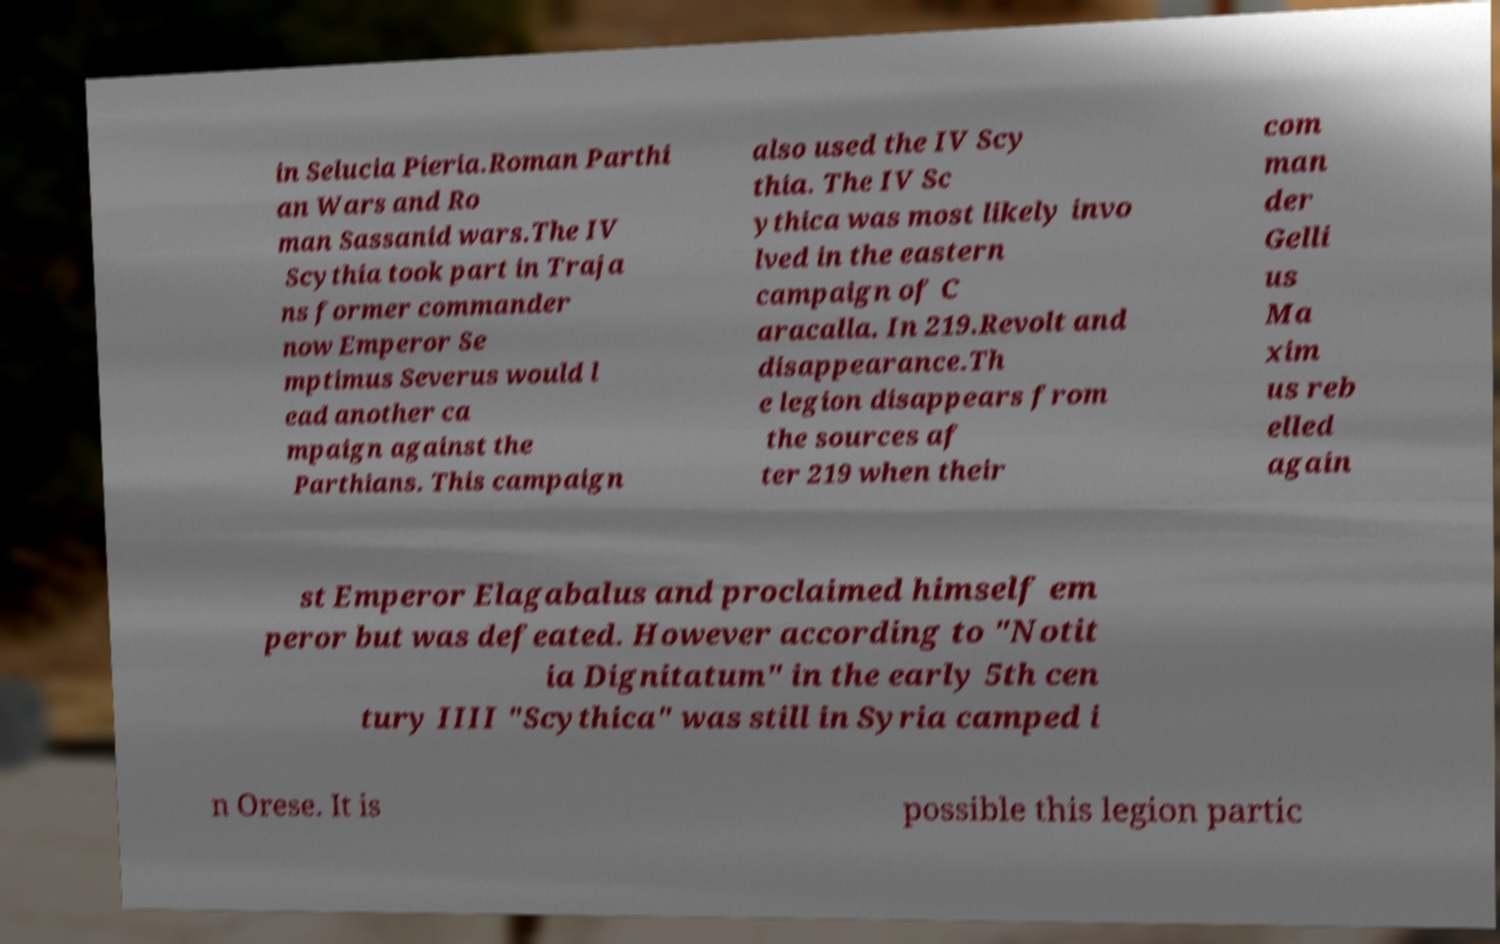I need the written content from this picture converted into text. Can you do that? in Selucia Pieria.Roman Parthi an Wars and Ro man Sassanid wars.The IV Scythia took part in Traja ns former commander now Emperor Se mptimus Severus would l ead another ca mpaign against the Parthians. This campaign also used the IV Scy thia. The IV Sc ythica was most likely invo lved in the eastern campaign of C aracalla. In 219.Revolt and disappearance.Th e legion disappears from the sources af ter 219 when their com man der Gelli us Ma xim us reb elled again st Emperor Elagabalus and proclaimed himself em peror but was defeated. However according to "Notit ia Dignitatum" in the early 5th cen tury IIII "Scythica" was still in Syria camped i n Orese. It is possible this legion partic 